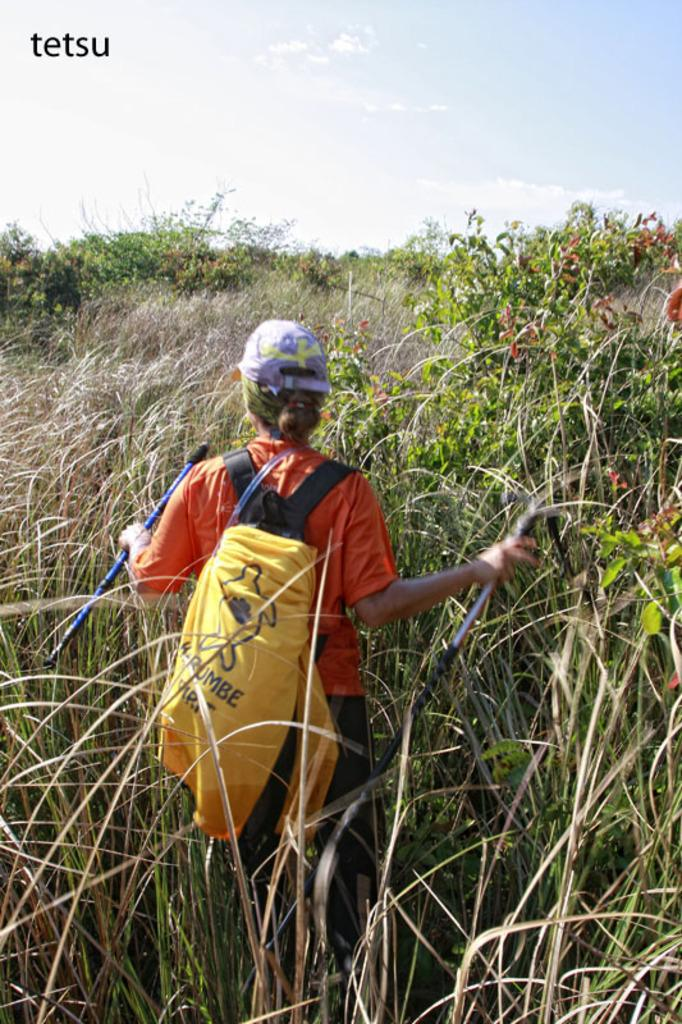Who is present in the image? There is a woman in the image. Where is the woman located? The woman is in the middle of a farm. What is the woman wearing? The woman is wearing an orange t-shirt, a purple cap, and black pants. What is the woman carrying in the image? The woman is carrying a bag. What type of riddle can be seen written on the wall in the image? There is no riddle written on the wall in the image. How many dogs are present in the image? There are no dogs present in the image. 